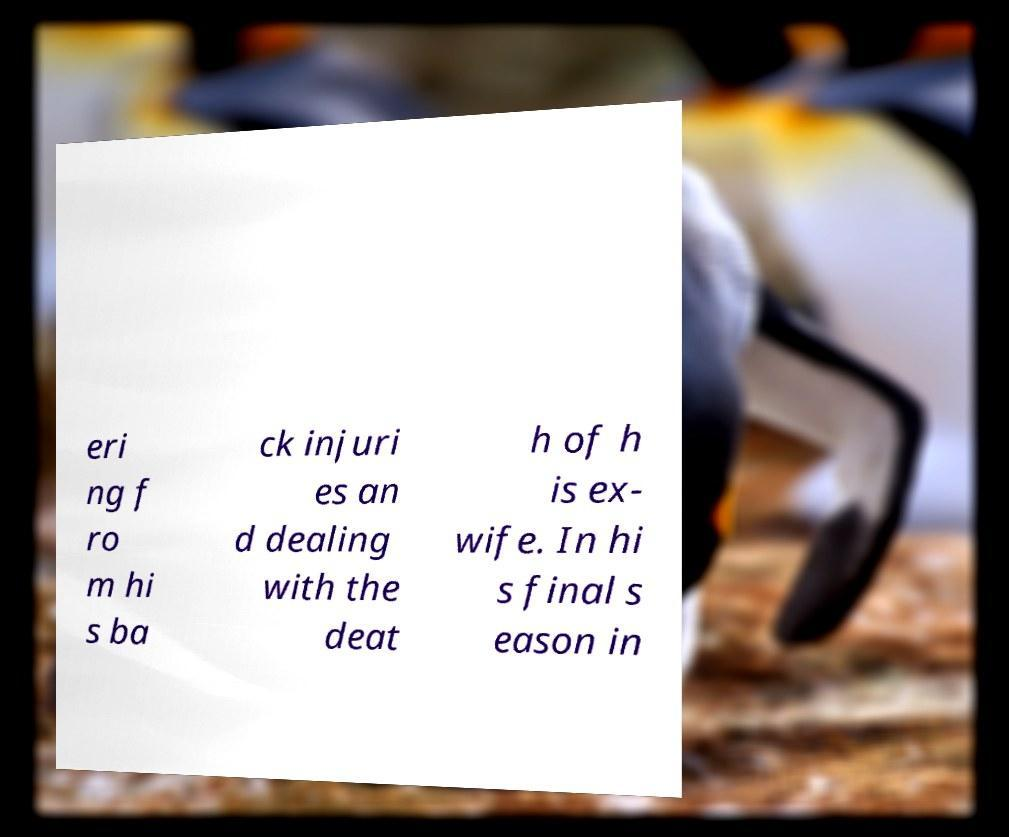I need the written content from this picture converted into text. Can you do that? eri ng f ro m hi s ba ck injuri es an d dealing with the deat h of h is ex- wife. In hi s final s eason in 